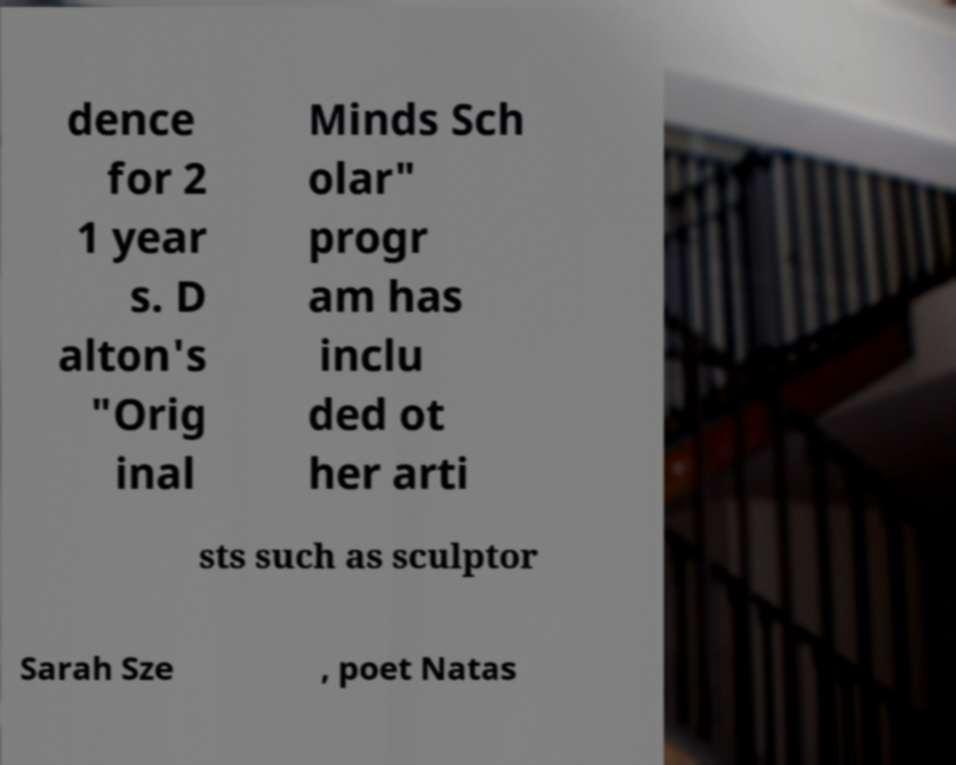Could you extract and type out the text from this image? dence for 2 1 year s. D alton's "Orig inal Minds Sch olar" progr am has inclu ded ot her arti sts such as sculptor Sarah Sze , poet Natas 